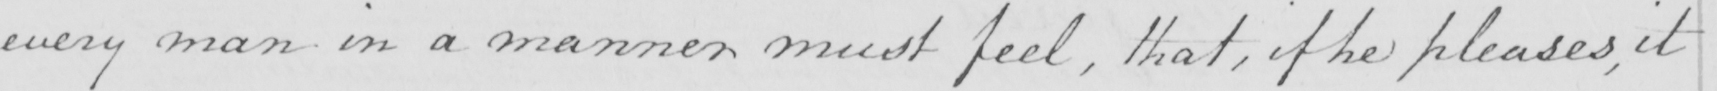Can you read and transcribe this handwriting? every man in a manner must feel , that , if he pleases , it 